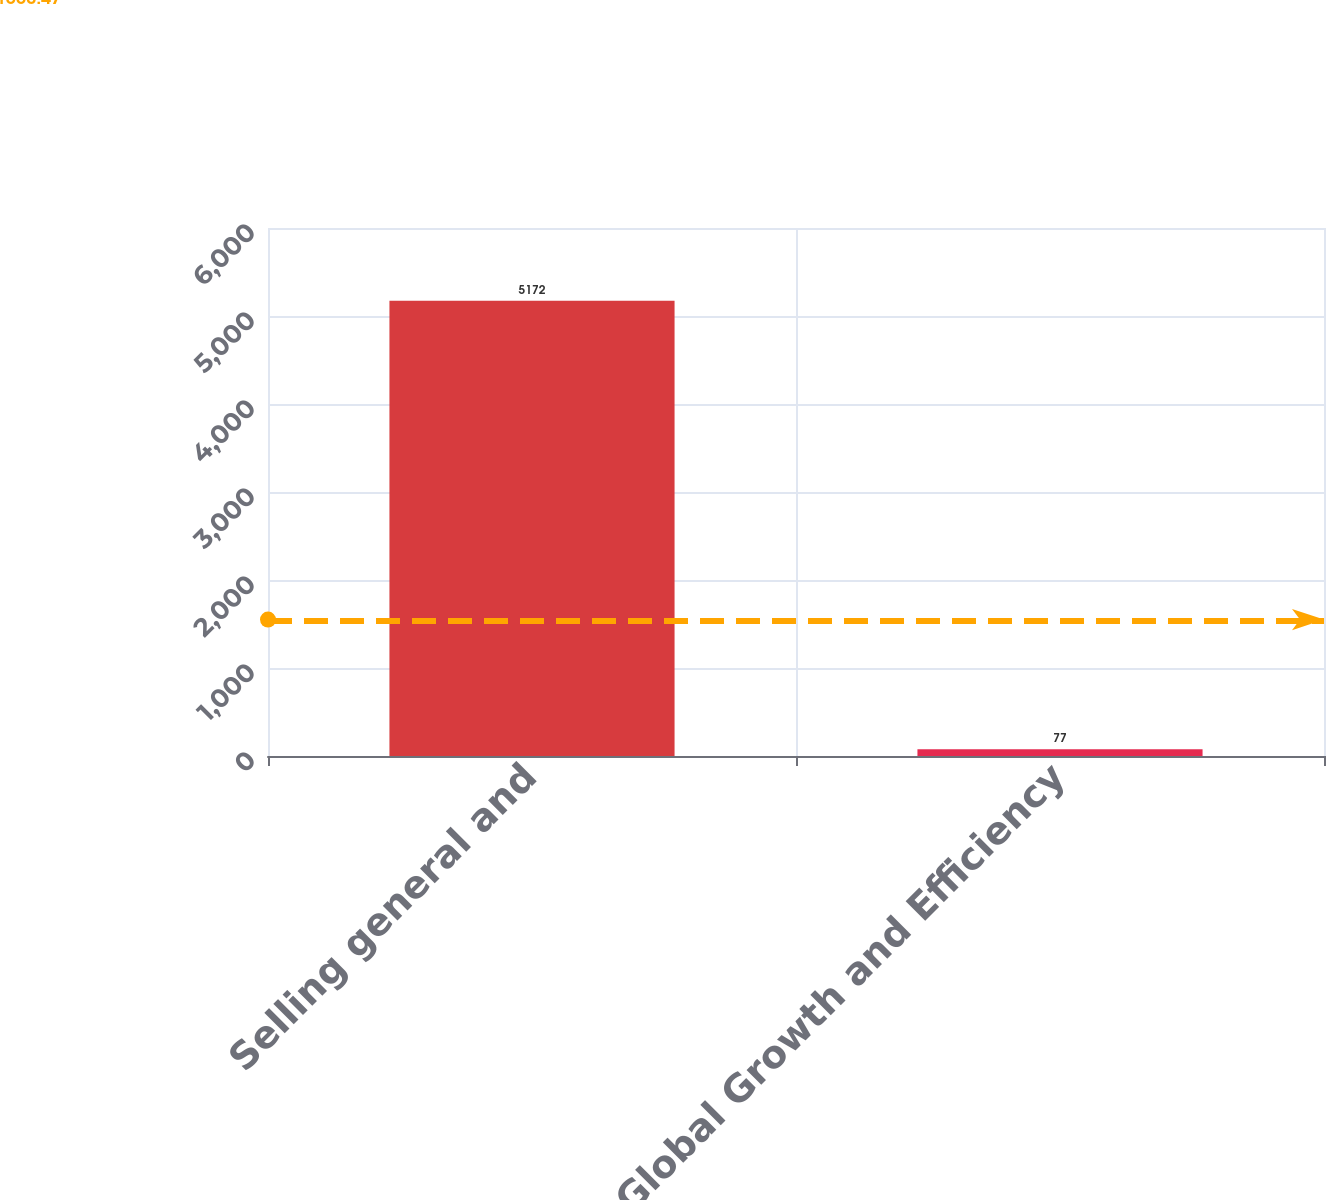Convert chart to OTSL. <chart><loc_0><loc_0><loc_500><loc_500><bar_chart><fcel>Selling general and<fcel>Global Growth and Efficiency<nl><fcel>5172<fcel>77<nl></chart> 